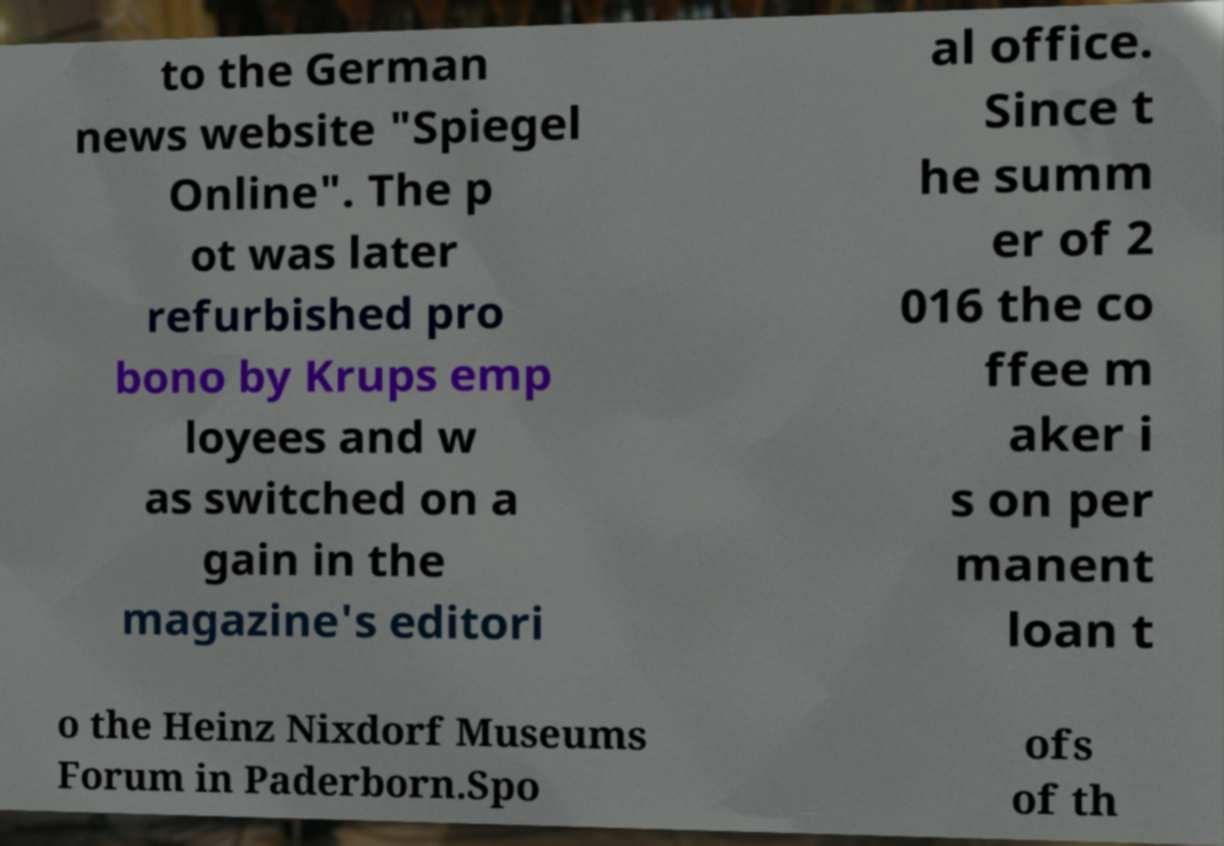Please identify and transcribe the text found in this image. to the German news website "Spiegel Online". The p ot was later refurbished pro bono by Krups emp loyees and w as switched on a gain in the magazine's editori al office. Since t he summ er of 2 016 the co ffee m aker i s on per manent loan t o the Heinz Nixdorf Museums Forum in Paderborn.Spo ofs of th 